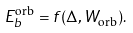<formula> <loc_0><loc_0><loc_500><loc_500>E _ { b } ^ { \text {orb} } = f ( \Delta , W _ { \text {orb} } ) .</formula> 